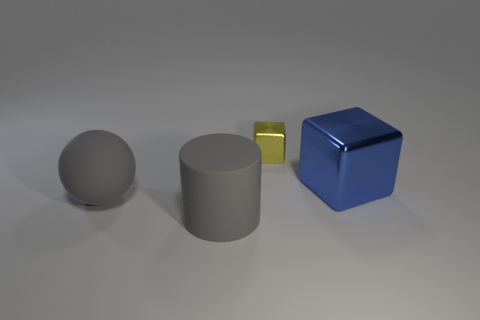Add 2 tiny green rubber spheres. How many objects exist? 6 Subtract all cylinders. How many objects are left? 3 Subtract all gray rubber balls. Subtract all large things. How many objects are left? 0 Add 3 small metallic blocks. How many small metallic blocks are left? 4 Add 4 large blue metallic blocks. How many large blue metallic blocks exist? 5 Subtract 0 green spheres. How many objects are left? 4 